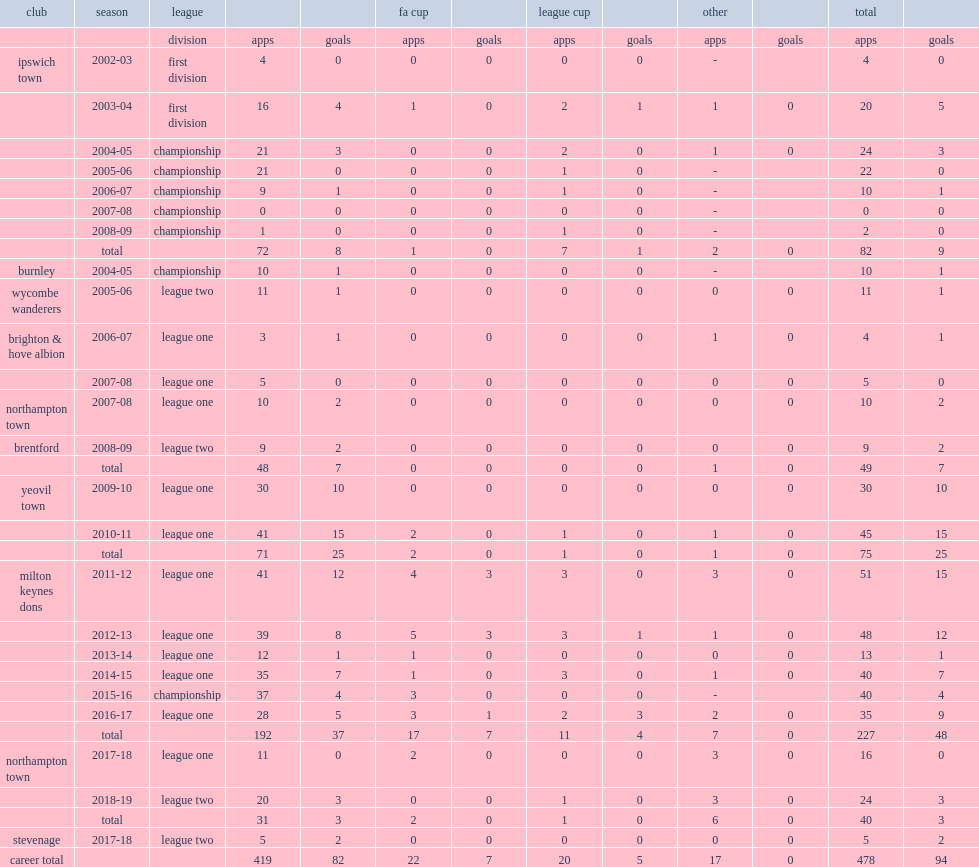Can you give me this table as a dict? {'header': ['club', 'season', 'league', '', '', 'fa cup', '', 'league cup', '', 'other', '', 'total', ''], 'rows': [['', '', 'division', 'apps', 'goals', 'apps', 'goals', 'apps', 'goals', 'apps', 'goals', 'apps', 'goals'], ['ipswich town', '2002-03', 'first division', '4', '0', '0', '0', '0', '0', '-', '', '4', '0'], ['', '2003-04', 'first division', '16', '4', '1', '0', '2', '1', '1', '0', '20', '5'], ['', '2004-05', 'championship', '21', '3', '0', '0', '2', '0', '1', '0', '24', '3'], ['', '2005-06', 'championship', '21', '0', '0', '0', '1', '0', '-', '', '22', '0'], ['', '2006-07', 'championship', '9', '1', '0', '0', '1', '0', '-', '', '10', '1'], ['', '2007-08', 'championship', '0', '0', '0', '0', '0', '0', '-', '', '0', '0'], ['', '2008-09', 'championship', '1', '0', '0', '0', '1', '0', '-', '', '2', '0'], ['', 'total', '', '72', '8', '1', '0', '7', '1', '2', '0', '82', '9'], ['burnley', '2004-05', 'championship', '10', '1', '0', '0', '0', '0', '-', '', '10', '1'], ['wycombe wanderers', '2005-06', 'league two', '11', '1', '0', '0', '0', '0', '0', '0', '11', '1'], ['brighton & hove albion', '2006-07', 'league one', '3', '1', '0', '0', '0', '0', '1', '0', '4', '1'], ['', '2007-08', 'league one', '5', '0', '0', '0', '0', '0', '0', '0', '5', '0'], ['northampton town', '2007-08', 'league one', '10', '2', '0', '0', '0', '0', '0', '0', '10', '2'], ['brentford', '2008-09', 'league two', '9', '2', '0', '0', '0', '0', '0', '0', '9', '2'], ['', 'total', '', '48', '7', '0', '0', '0', '0', '1', '0', '49', '7'], ['yeovil town', '2009-10', 'league one', '30', '10', '0', '0', '0', '0', '0', '0', '30', '10'], ['', '2010-11', 'league one', '41', '15', '2', '0', '1', '0', '1', '0', '45', '15'], ['', 'total', '', '71', '25', '2', '0', '1', '0', '1', '0', '75', '25'], ['milton keynes dons', '2011-12', 'league one', '41', '12', '4', '3', '3', '0', '3', '0', '51', '15'], ['', '2012-13', 'league one', '39', '8', '5', '3', '3', '1', '1', '0', '48', '12'], ['', '2013-14', 'league one', '12', '1', '1', '0', '0', '0', '0', '0', '13', '1'], ['', '2014-15', 'league one', '35', '7', '1', '0', '3', '0', '1', '0', '40', '7'], ['', '2015-16', 'championship', '37', '4', '3', '0', '0', '0', '-', '', '40', '4'], ['', '2016-17', 'league one', '28', '5', '3', '1', '2', '3', '2', '0', '35', '9'], ['', 'total', '', '192', '37', '17', '7', '11', '4', '7', '0', '227', '48'], ['northampton town', '2017-18', 'league one', '11', '0', '2', '0', '0', '0', '3', '0', '16', '0'], ['', '2018-19', 'league two', '20', '3', '0', '0', '1', '0', '3', '0', '24', '3'], ['', 'total', '', '31', '3', '2', '0', '1', '0', '6', '0', '40', '3'], ['stevenage', '2017-18', 'league two', '5', '2', '0', '0', '0', '0', '0', '0', '5', '2'], ['career total', '', '', '419', '82', '22', '7', '20', '5', '17', '0', '478', '94']]} How many appearances did bowditch make in 6 seasons till 2016-17 with the club milton keynes dons? 227.0. How many goals did bowditch make in 6 seasons till 2016-17 with the club milton keynes dons? 48.0. 